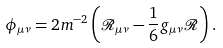<formula> <loc_0><loc_0><loc_500><loc_500>\phi _ { \mu \nu } = 2 m ^ { - 2 } \left ( \mathcal { R } _ { \mu \nu } - \frac { 1 } { 6 } g _ { \mu \nu } \mathcal { R } \right ) .</formula> 